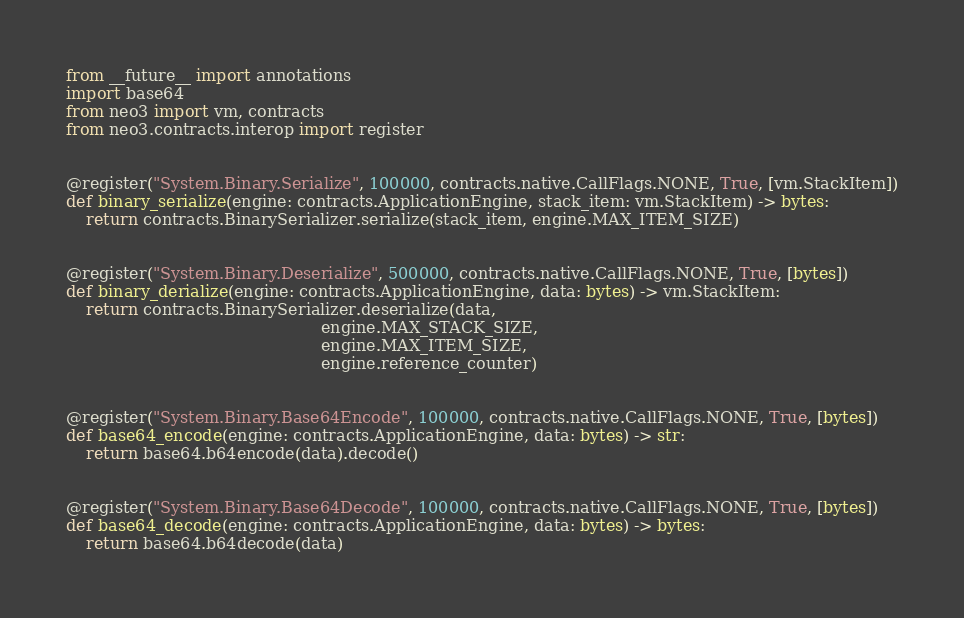<code> <loc_0><loc_0><loc_500><loc_500><_Python_>from __future__ import annotations
import base64
from neo3 import vm, contracts
from neo3.contracts.interop import register


@register("System.Binary.Serialize", 100000, contracts.native.CallFlags.NONE, True, [vm.StackItem])
def binary_serialize(engine: contracts.ApplicationEngine, stack_item: vm.StackItem) -> bytes:
    return contracts.BinarySerializer.serialize(stack_item, engine.MAX_ITEM_SIZE)


@register("System.Binary.Deserialize", 500000, contracts.native.CallFlags.NONE, True, [bytes])
def binary_derialize(engine: contracts.ApplicationEngine, data: bytes) -> vm.StackItem:
    return contracts.BinarySerializer.deserialize(data,
                                                  engine.MAX_STACK_SIZE,
                                                  engine.MAX_ITEM_SIZE,
                                                  engine.reference_counter)


@register("System.Binary.Base64Encode", 100000, contracts.native.CallFlags.NONE, True, [bytes])
def base64_encode(engine: contracts.ApplicationEngine, data: bytes) -> str:
    return base64.b64encode(data).decode()


@register("System.Binary.Base64Decode", 100000, contracts.native.CallFlags.NONE, True, [bytes])
def base64_decode(engine: contracts.ApplicationEngine, data: bytes) -> bytes:
    return base64.b64decode(data)
</code> 